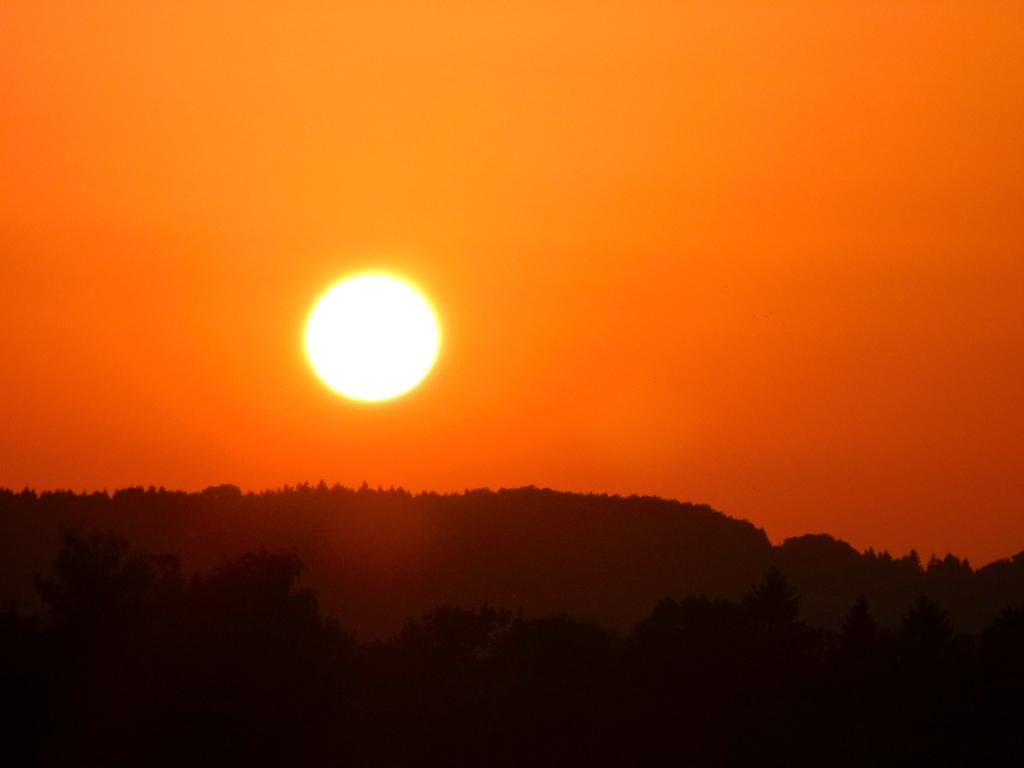What celestial body can be seen in the sky in the image? The sun is visible in the sky in the image. What type of vegetation is present in the background of the image? There is a group of trees in the background of the image. How many snakes are slithering through the trees in the image? There are no snakes present in the image; it features a group of trees and the sun in the sky. 